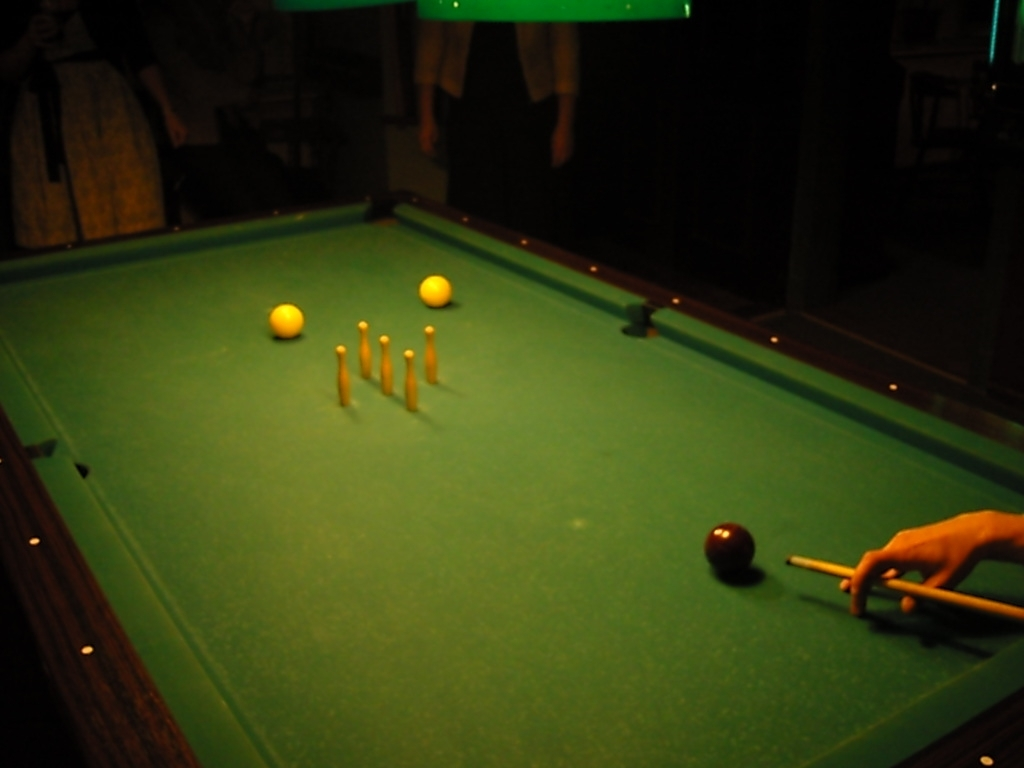Is the main subject, the pool table, intact? The pool table appears to be in good condition, with no visible tears or damage to the felt surface. All the balls and cues necessary for gameplay are present, which suggests it’s ready for use. The table's pockets, railings, and legs also seem intact, indicating that it has been well-maintained. 